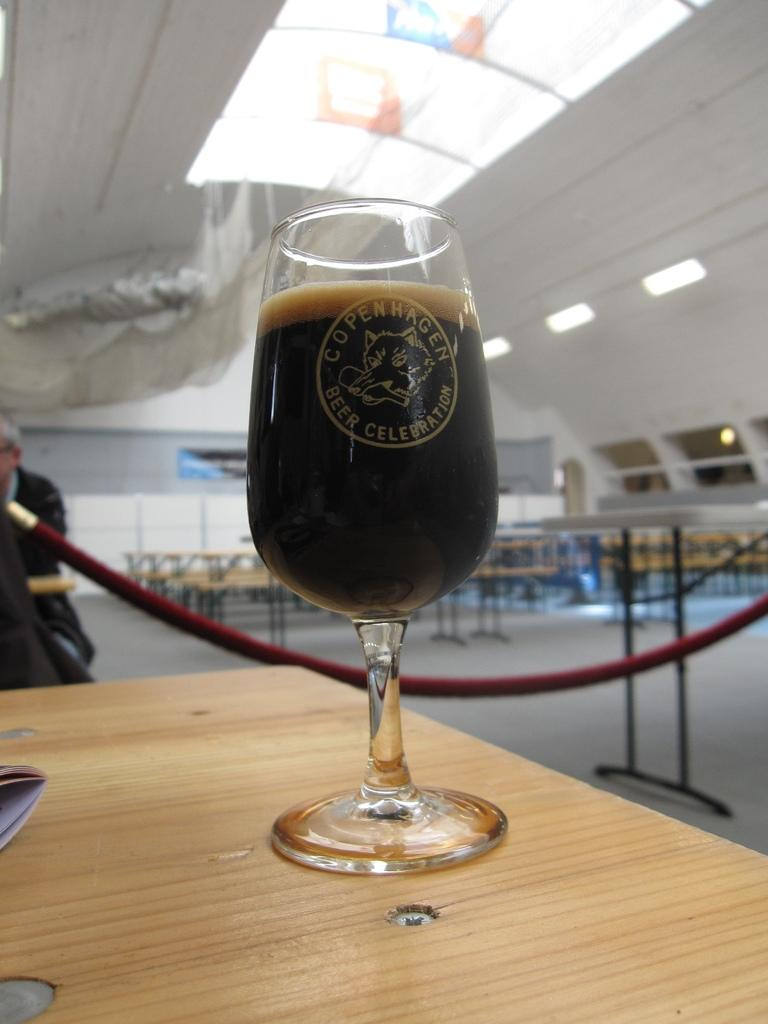What is on the table in the image? There is a glass of beer on the table. Can you describe the surrounding area in the image? There are other tables visible in the image. What is located on the left side of the image? There is a person on the left side of the image. What can be seen at the top of the image? Lights are visible at the top of the image. What type of bread is being served for breakfast in the image? There is no bread or breakfast scene present in the image; it features a glass of beer on a table. 